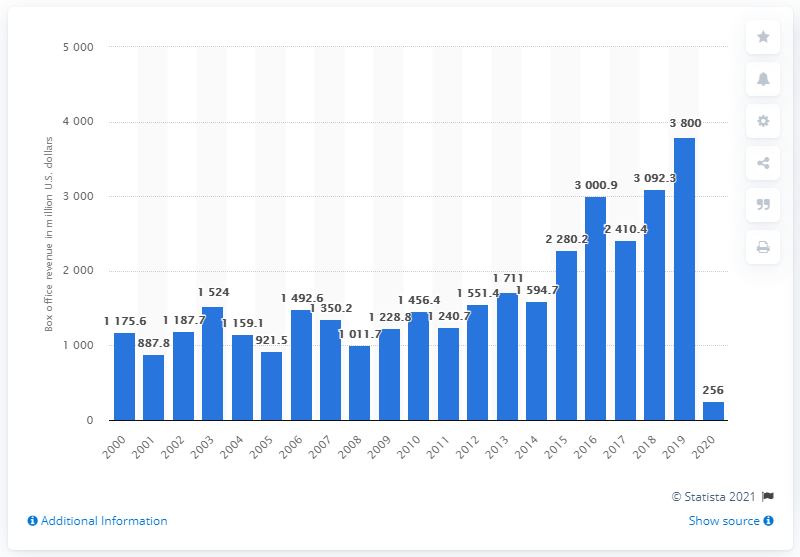Give some essential details in this illustration. In 2020, Disney generated approximately 256 million dollars in revenue in the U.S. and Canada. The year 2019 was a significant year for The Walt Disney Company. 